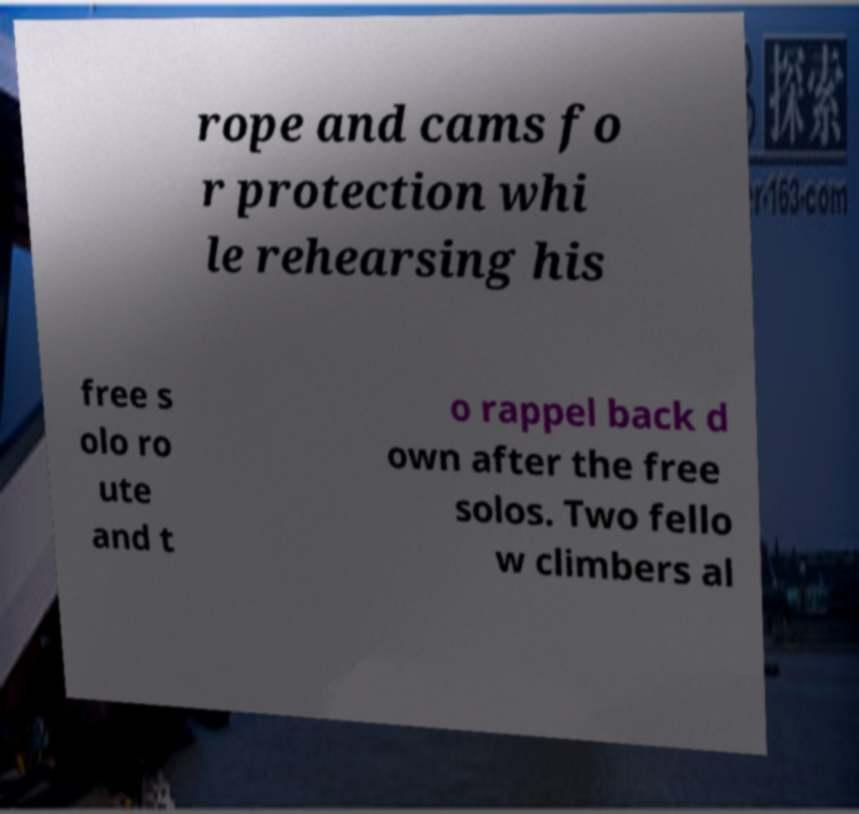For documentation purposes, I need the text within this image transcribed. Could you provide that? rope and cams fo r protection whi le rehearsing his free s olo ro ute and t o rappel back d own after the free solos. Two fello w climbers al 